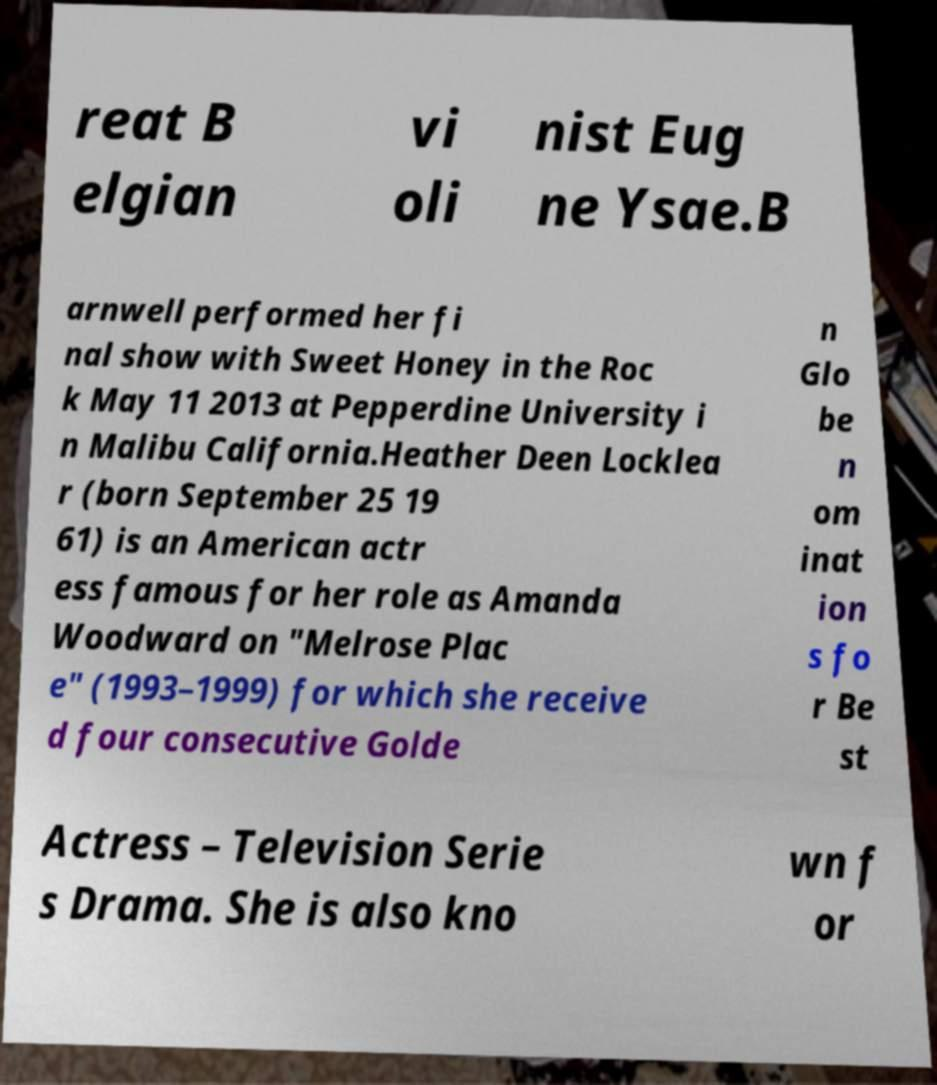I need the written content from this picture converted into text. Can you do that? reat B elgian vi oli nist Eug ne Ysae.B arnwell performed her fi nal show with Sweet Honey in the Roc k May 11 2013 at Pepperdine University i n Malibu California.Heather Deen Locklea r (born September 25 19 61) is an American actr ess famous for her role as Amanda Woodward on "Melrose Plac e" (1993–1999) for which she receive d four consecutive Golde n Glo be n om inat ion s fo r Be st Actress – Television Serie s Drama. She is also kno wn f or 